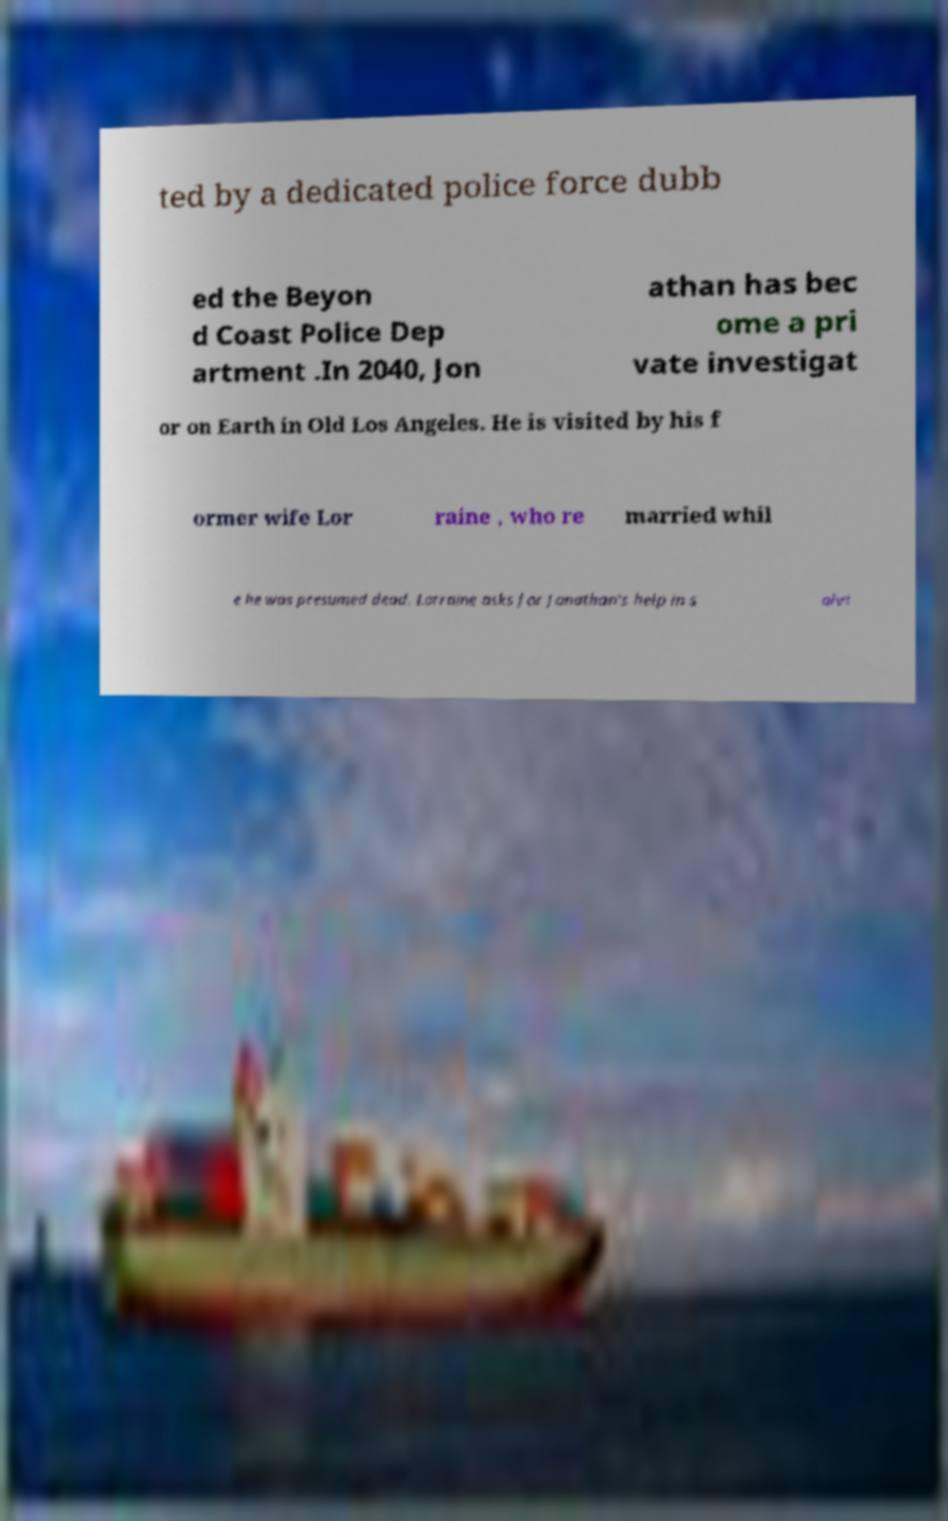I need the written content from this picture converted into text. Can you do that? ted by a dedicated police force dubb ed the Beyon d Coast Police Dep artment .In 2040, Jon athan has bec ome a pri vate investigat or on Earth in Old Los Angeles. He is visited by his f ormer wife Lor raine , who re married whil e he was presumed dead. Lorraine asks for Jonathan's help in s olvi 